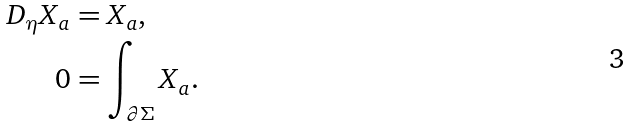Convert formula to latex. <formula><loc_0><loc_0><loc_500><loc_500>D _ { \eta } X _ { a } & = X _ { a } , \\ 0 & = \int _ { \partial \Sigma } X _ { a } .</formula> 